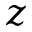<formula> <loc_0><loc_0><loc_500><loc_500>z</formula> 